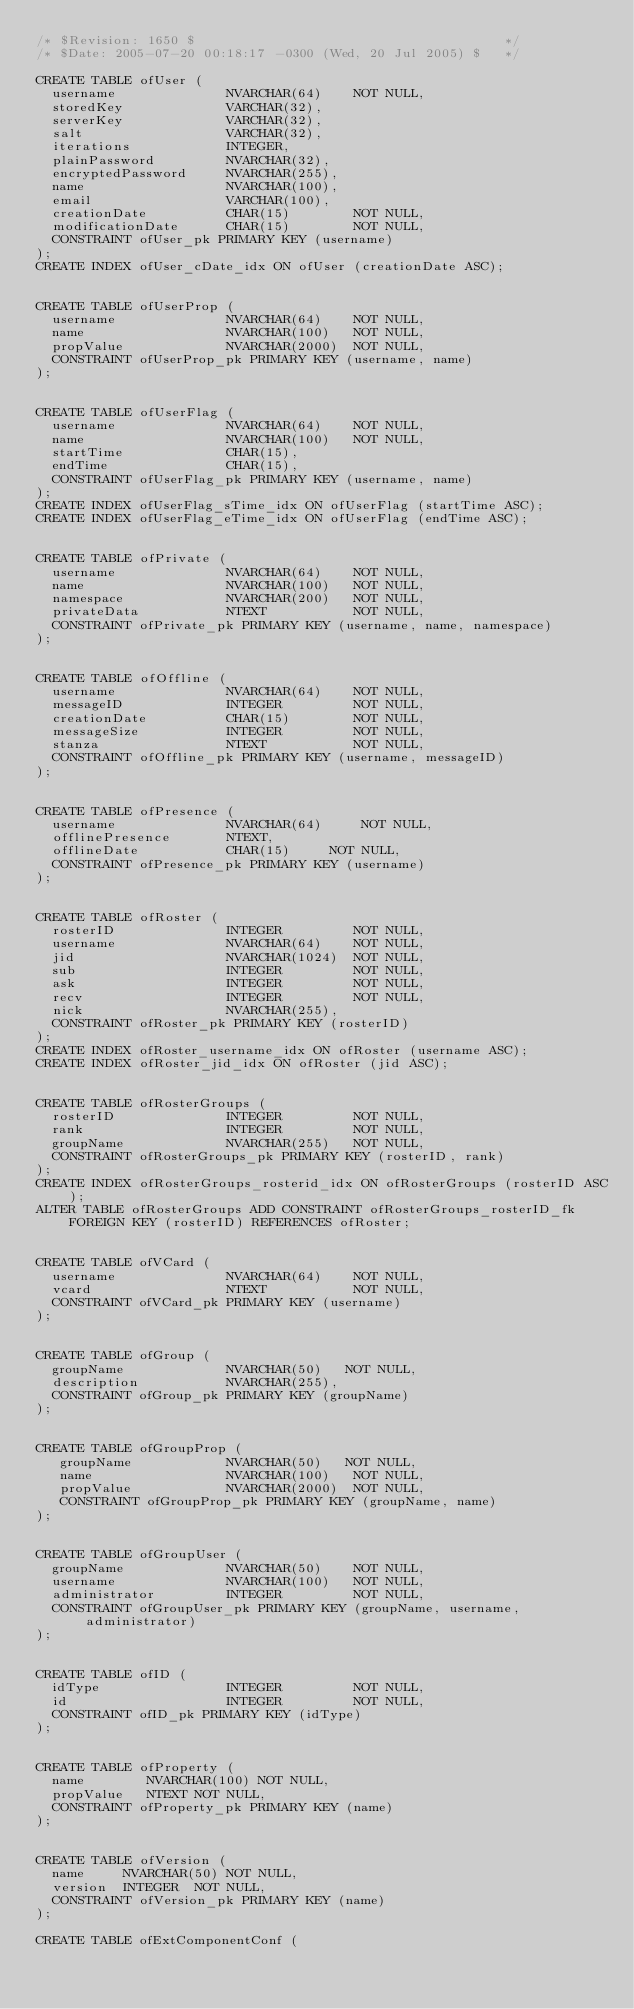<code> <loc_0><loc_0><loc_500><loc_500><_SQL_>/* $Revision: 1650 $                                       */
/* $Date: 2005-07-20 00:18:17 -0300 (Wed, 20 Jul 2005) $   */

CREATE TABLE ofUser (
  username              NVARCHAR(64)    NOT NULL,
  storedKey             VARCHAR(32),
  serverKey             VARCHAR(32),
  salt                  VARCHAR(32),
  iterations            INTEGER,
  plainPassword         NVARCHAR(32),
  encryptedPassword     NVARCHAR(255),
  name                  NVARCHAR(100),
  email                 VARCHAR(100),
  creationDate          CHAR(15)        NOT NULL,
  modificationDate      CHAR(15)        NOT NULL,
  CONSTRAINT ofUser_pk PRIMARY KEY (username)
);
CREATE INDEX ofUser_cDate_idx ON ofUser (creationDate ASC);


CREATE TABLE ofUserProp (
  username              NVARCHAR(64)    NOT NULL,
  name                  NVARCHAR(100)   NOT NULL,
  propValue             NVARCHAR(2000)  NOT NULL,
  CONSTRAINT ofUserProp_pk PRIMARY KEY (username, name)
);


CREATE TABLE ofUserFlag (
  username              NVARCHAR(64)    NOT NULL,
  name                  NVARCHAR(100)   NOT NULL,
  startTime             CHAR(15),
  endTime               CHAR(15),
  CONSTRAINT ofUserFlag_pk PRIMARY KEY (username, name)
);
CREATE INDEX ofUserFlag_sTime_idx ON ofUserFlag (startTime ASC);
CREATE INDEX ofUserFlag_eTime_idx ON ofUserFlag (endTime ASC);


CREATE TABLE ofPrivate (
  username              NVARCHAR(64)    NOT NULL,
  name                  NVARCHAR(100)   NOT NULL,
  namespace             NVARCHAR(200)   NOT NULL,
  privateData           NTEXT           NOT NULL,
  CONSTRAINT ofPrivate_pk PRIMARY KEY (username, name, namespace)
);


CREATE TABLE ofOffline (
  username              NVARCHAR(64)    NOT NULL,
  messageID             INTEGER         NOT NULL,
  creationDate          CHAR(15)        NOT NULL,
  messageSize           INTEGER         NOT NULL,
  stanza                NTEXT           NOT NULL,
  CONSTRAINT ofOffline_pk PRIMARY KEY (username, messageID)
);


CREATE TABLE ofPresence (
  username              NVARCHAR(64)     NOT NULL,
  offlinePresence       NTEXT,
  offlineDate           CHAR(15)     NOT NULL,
  CONSTRAINT ofPresence_pk PRIMARY KEY (username)
);


CREATE TABLE ofRoster (
  rosterID              INTEGER         NOT NULL,
  username              NVARCHAR(64)    NOT NULL,
  jid                   NVARCHAR(1024)  NOT NULL,
  sub                   INTEGER         NOT NULL,
  ask                   INTEGER         NOT NULL,
  recv                  INTEGER         NOT NULL,
  nick                  NVARCHAR(255),
  CONSTRAINT ofRoster_pk PRIMARY KEY (rosterID)
);
CREATE INDEX ofRoster_username_idx ON ofRoster (username ASC);
CREATE INDEX ofRoster_jid_idx ON ofRoster (jid ASC);


CREATE TABLE ofRosterGroups (
  rosterID              INTEGER         NOT NULL,
  rank                  INTEGER         NOT NULL,
  groupName             NVARCHAR(255)   NOT NULL,
  CONSTRAINT ofRosterGroups_pk PRIMARY KEY (rosterID, rank)
);
CREATE INDEX ofRosterGroups_rosterid_idx ON ofRosterGroups (rosterID ASC);
ALTER TABLE ofRosterGroups ADD CONSTRAINT ofRosterGroups_rosterID_fk FOREIGN KEY (rosterID) REFERENCES ofRoster;


CREATE TABLE ofVCard (
  username              NVARCHAR(64)    NOT NULL,
  vcard                 NTEXT           NOT NULL,
  CONSTRAINT ofVCard_pk PRIMARY KEY (username)
);


CREATE TABLE ofGroup (
  groupName             NVARCHAR(50)   NOT NULL,
  description           NVARCHAR(255),
  CONSTRAINT ofGroup_pk PRIMARY KEY (groupName)
);


CREATE TABLE ofGroupProp (
   groupName            NVARCHAR(50)   NOT NULL,
   name                 NVARCHAR(100)   NOT NULL,
   propValue            NVARCHAR(2000)  NOT NULL,
   CONSTRAINT ofGroupProp_pk PRIMARY KEY (groupName, name)
);


CREATE TABLE ofGroupUser (
  groupName             NVARCHAR(50)    NOT NULL,
  username              NVARCHAR(100)   NOT NULL,
  administrator         INTEGER         NOT NULL,
  CONSTRAINT ofGroupUser_pk PRIMARY KEY (groupName, username, administrator)
);


CREATE TABLE ofID (
  idType                INTEGER         NOT NULL,
  id                    INTEGER         NOT NULL,
  CONSTRAINT ofID_pk PRIMARY KEY (idType)
);


CREATE TABLE ofProperty (
  name        NVARCHAR(100) NOT NULL,
  propValue   NTEXT NOT NULL,
  CONSTRAINT ofProperty_pk PRIMARY KEY (name)
);


CREATE TABLE ofVersion (
  name     NVARCHAR(50) NOT NULL,
  version  INTEGER  NOT NULL,
  CONSTRAINT ofVersion_pk PRIMARY KEY (name)
);

CREATE TABLE ofExtComponentConf (</code> 